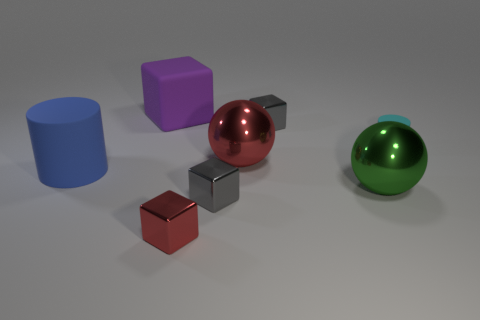Subtract all purple cubes. Subtract all gray cylinders. How many cubes are left? 3 Add 2 tiny gray objects. How many objects exist? 10 Subtract all cylinders. How many objects are left? 6 Add 7 big blue cylinders. How many big blue cylinders are left? 8 Add 6 large cyan rubber things. How many large cyan rubber things exist? 6 Subtract 0 yellow balls. How many objects are left? 8 Subtract all rubber cylinders. Subtract all purple objects. How many objects are left? 5 